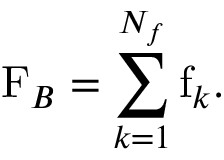<formula> <loc_0><loc_0><loc_500><loc_500>F _ { B } = \sum _ { k = 1 } ^ { N _ { f } } f _ { k } .</formula> 